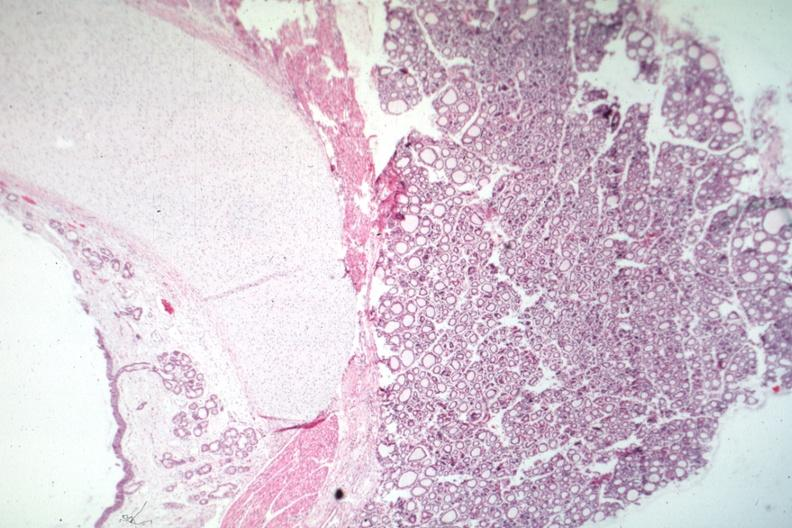what is present?
Answer the question using a single word or phrase. Endocrine 